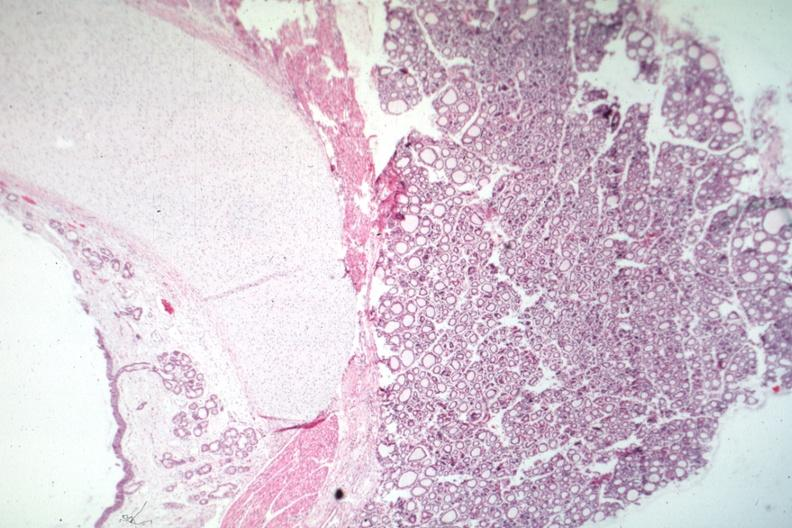what is present?
Answer the question using a single word or phrase. Endocrine 